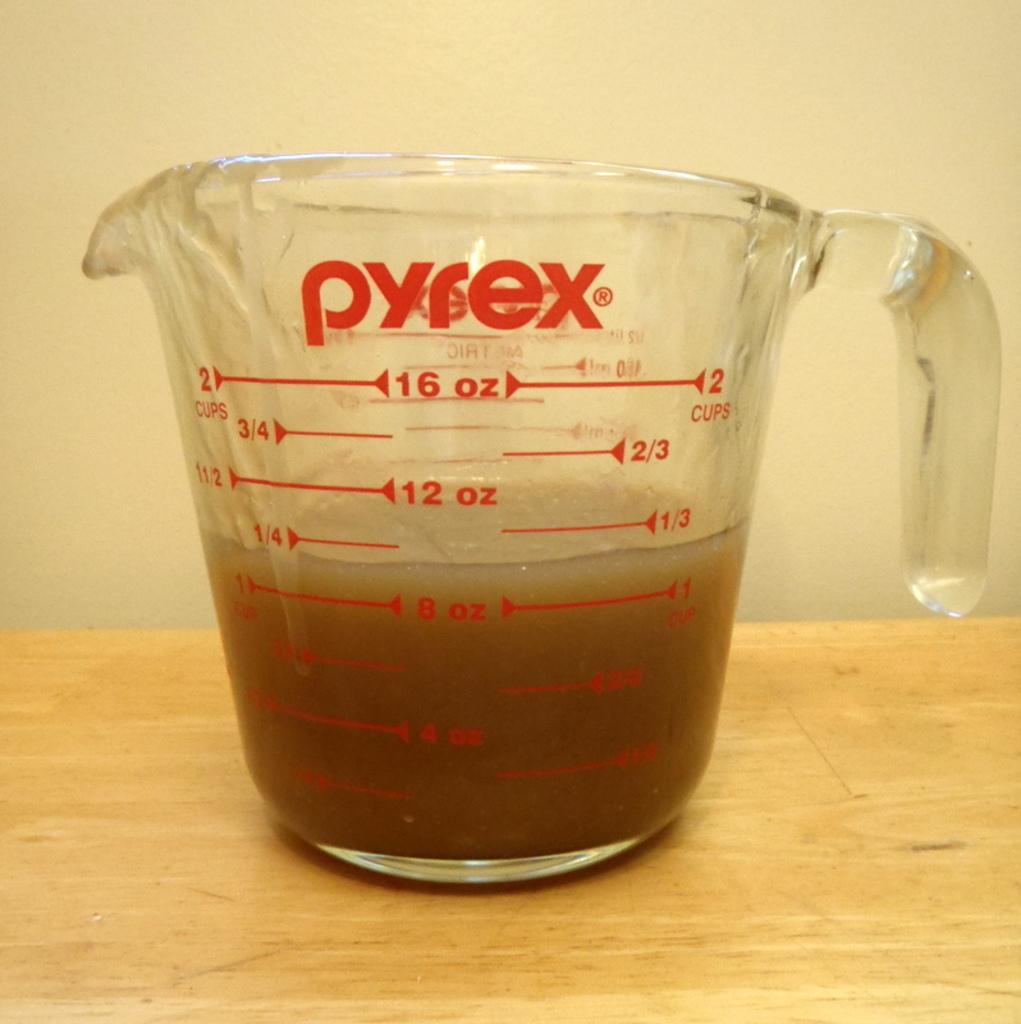What is the top oz?
Your answer should be compact. 16. What brand is this cup?
Make the answer very short. Pyrex. 